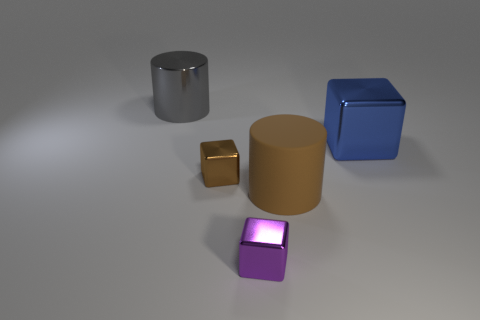The large object in front of the block that is to the right of the small purple shiny cube is what shape?
Keep it short and to the point. Cylinder. Does the cylinder that is in front of the tiny brown thing have the same color as the big block?
Your answer should be compact. No. There is a large object that is both to the left of the blue object and right of the big gray cylinder; what is its color?
Your response must be concise. Brown. Is there a small brown cube that has the same material as the gray object?
Your answer should be very brief. Yes. The blue metal object is what size?
Your answer should be very brief. Large. There is a cylinder that is right of the large metallic thing to the left of the matte thing; what size is it?
Make the answer very short. Large. What is the material of the brown thing that is the same shape as the blue thing?
Provide a succinct answer. Metal. How many green matte blocks are there?
Keep it short and to the point. 0. There is a large cylinder that is on the right side of the large metallic object to the left of the small block behind the small purple cube; what is its color?
Make the answer very short. Brown. Are there fewer big purple shiny spheres than brown rubber objects?
Your answer should be very brief. Yes. 